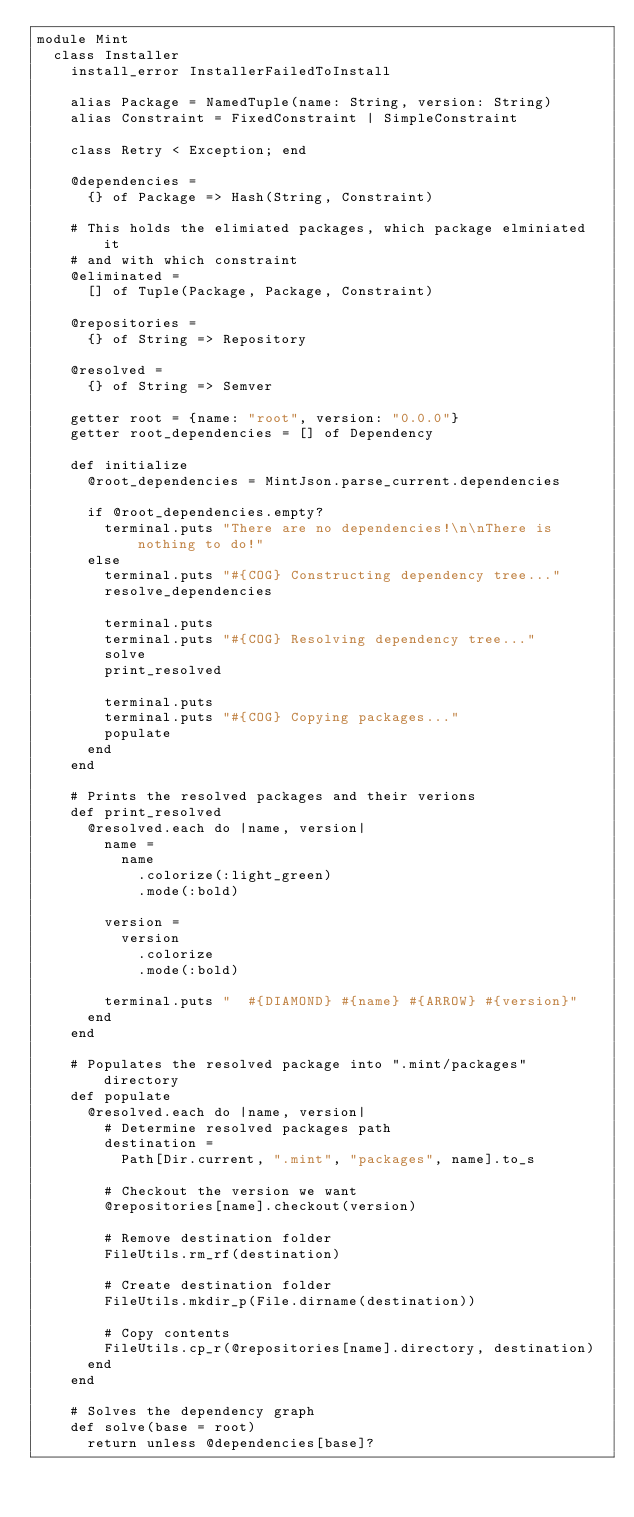<code> <loc_0><loc_0><loc_500><loc_500><_Crystal_>module Mint
  class Installer
    install_error InstallerFailedToInstall

    alias Package = NamedTuple(name: String, version: String)
    alias Constraint = FixedConstraint | SimpleConstraint

    class Retry < Exception; end

    @dependencies =
      {} of Package => Hash(String, Constraint)

    # This holds the elimiated packages, which package elminiated it
    # and with which constraint
    @eliminated =
      [] of Tuple(Package, Package, Constraint)

    @repositories =
      {} of String => Repository

    @resolved =
      {} of String => Semver

    getter root = {name: "root", version: "0.0.0"}
    getter root_dependencies = [] of Dependency

    def initialize
      @root_dependencies = MintJson.parse_current.dependencies

      if @root_dependencies.empty?
        terminal.puts "There are no dependencies!\n\nThere is nothing to do!"
      else
        terminal.puts "#{COG} Constructing dependency tree..."
        resolve_dependencies

        terminal.puts
        terminal.puts "#{COG} Resolving dependency tree..."
        solve
        print_resolved

        terminal.puts
        terminal.puts "#{COG} Copying packages..."
        populate
      end
    end

    # Prints the resolved packages and their verions
    def print_resolved
      @resolved.each do |name, version|
        name =
          name
            .colorize(:light_green)
            .mode(:bold)

        version =
          version
            .colorize
            .mode(:bold)

        terminal.puts "  #{DIAMOND} #{name} #{ARROW} #{version}"
      end
    end

    # Populates the resolved package into ".mint/packages" directory
    def populate
      @resolved.each do |name, version|
        # Determine resolved packages path
        destination =
          Path[Dir.current, ".mint", "packages", name].to_s

        # Checkout the version we want
        @repositories[name].checkout(version)

        # Remove destination folder
        FileUtils.rm_rf(destination)

        # Create destination folder
        FileUtils.mkdir_p(File.dirname(destination))

        # Copy contents
        FileUtils.cp_r(@repositories[name].directory, destination)
      end
    end

    # Solves the dependency graph
    def solve(base = root)
      return unless @dependencies[base]?
</code> 